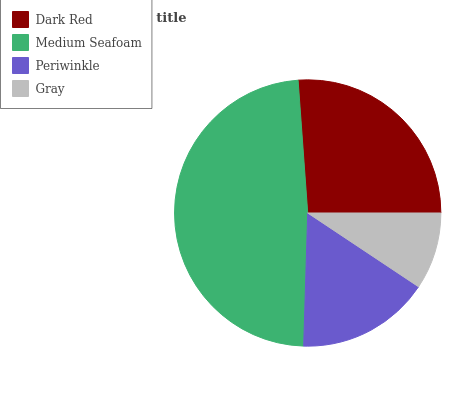Is Gray the minimum?
Answer yes or no. Yes. Is Medium Seafoam the maximum?
Answer yes or no. Yes. Is Periwinkle the minimum?
Answer yes or no. No. Is Periwinkle the maximum?
Answer yes or no. No. Is Medium Seafoam greater than Periwinkle?
Answer yes or no. Yes. Is Periwinkle less than Medium Seafoam?
Answer yes or no. Yes. Is Periwinkle greater than Medium Seafoam?
Answer yes or no. No. Is Medium Seafoam less than Periwinkle?
Answer yes or no. No. Is Dark Red the high median?
Answer yes or no. Yes. Is Periwinkle the low median?
Answer yes or no. Yes. Is Periwinkle the high median?
Answer yes or no. No. Is Medium Seafoam the low median?
Answer yes or no. No. 